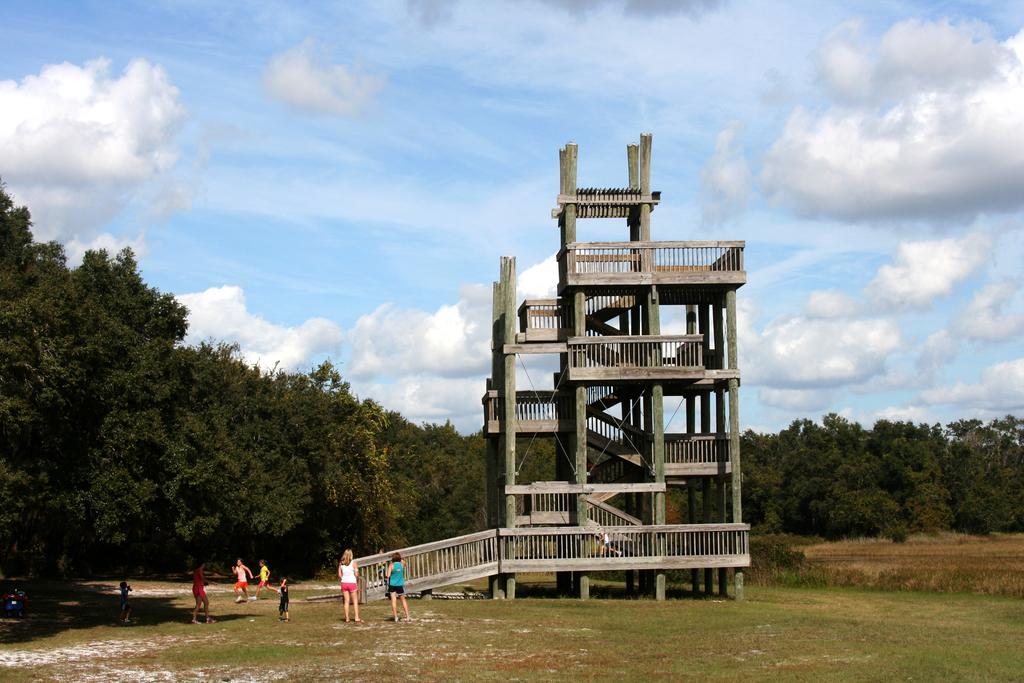What type of structure is in the image? There is a building in the image. What are the people in the image doing? The people are on the grass in the image. What type of vegetation is present in the image? Trees are present around the area in the image, and grass is visible. What type of popcorn is being sold at the station in the image? There is no popcorn or station present in the image. 